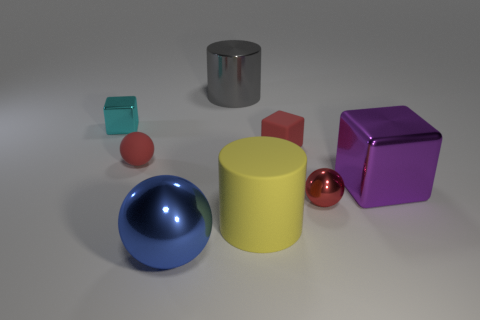What number of things are either small red matte objects to the right of the yellow rubber cylinder or shiny blocks?
Your answer should be very brief. 3. Is the number of tiny yellow spheres greater than the number of blue spheres?
Ensure brevity in your answer.  No. Are there any red metallic spheres of the same size as the blue thing?
Your answer should be very brief. No. What number of objects are either cylinders behind the small red matte sphere or tiny objects that are right of the big metallic cylinder?
Ensure brevity in your answer.  3. The metal thing behind the metal cube that is on the left side of the red matte sphere is what color?
Offer a very short reply. Gray. What color is the small block that is the same material as the big purple thing?
Ensure brevity in your answer.  Cyan. How many blocks are the same color as the tiny rubber ball?
Your response must be concise. 1. What number of objects are tiny blue metal cylinders or blue objects?
Keep it short and to the point. 1. What is the shape of the blue metallic object that is the same size as the gray cylinder?
Ensure brevity in your answer.  Sphere. What number of large objects are on the right side of the large blue thing and to the left of the matte block?
Ensure brevity in your answer.  2. 